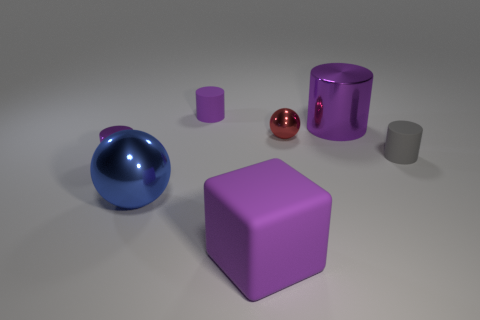How many purple cylinders must be subtracted to get 1 purple cylinders? 2 Subtract all green cubes. How many purple cylinders are left? 3 Subtract all green cylinders. Subtract all brown spheres. How many cylinders are left? 4 Add 3 red metallic things. How many objects exist? 10 Subtract all cubes. How many objects are left? 6 Add 3 things. How many things are left? 10 Add 5 large yellow rubber cubes. How many large yellow rubber cubes exist? 5 Subtract 1 blue balls. How many objects are left? 6 Subtract all small cyan cubes. Subtract all tiny gray things. How many objects are left? 6 